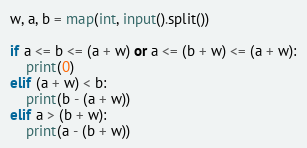Convert code to text. <code><loc_0><loc_0><loc_500><loc_500><_Python_>w, a, b = map(int, input().split())

if a <= b <= (a + w) or a <= (b + w) <= (a + w):
    print(0)
elif (a + w) < b:
    print(b - (a + w))
elif a > (b + w):
    print(a - (b + w))
</code> 